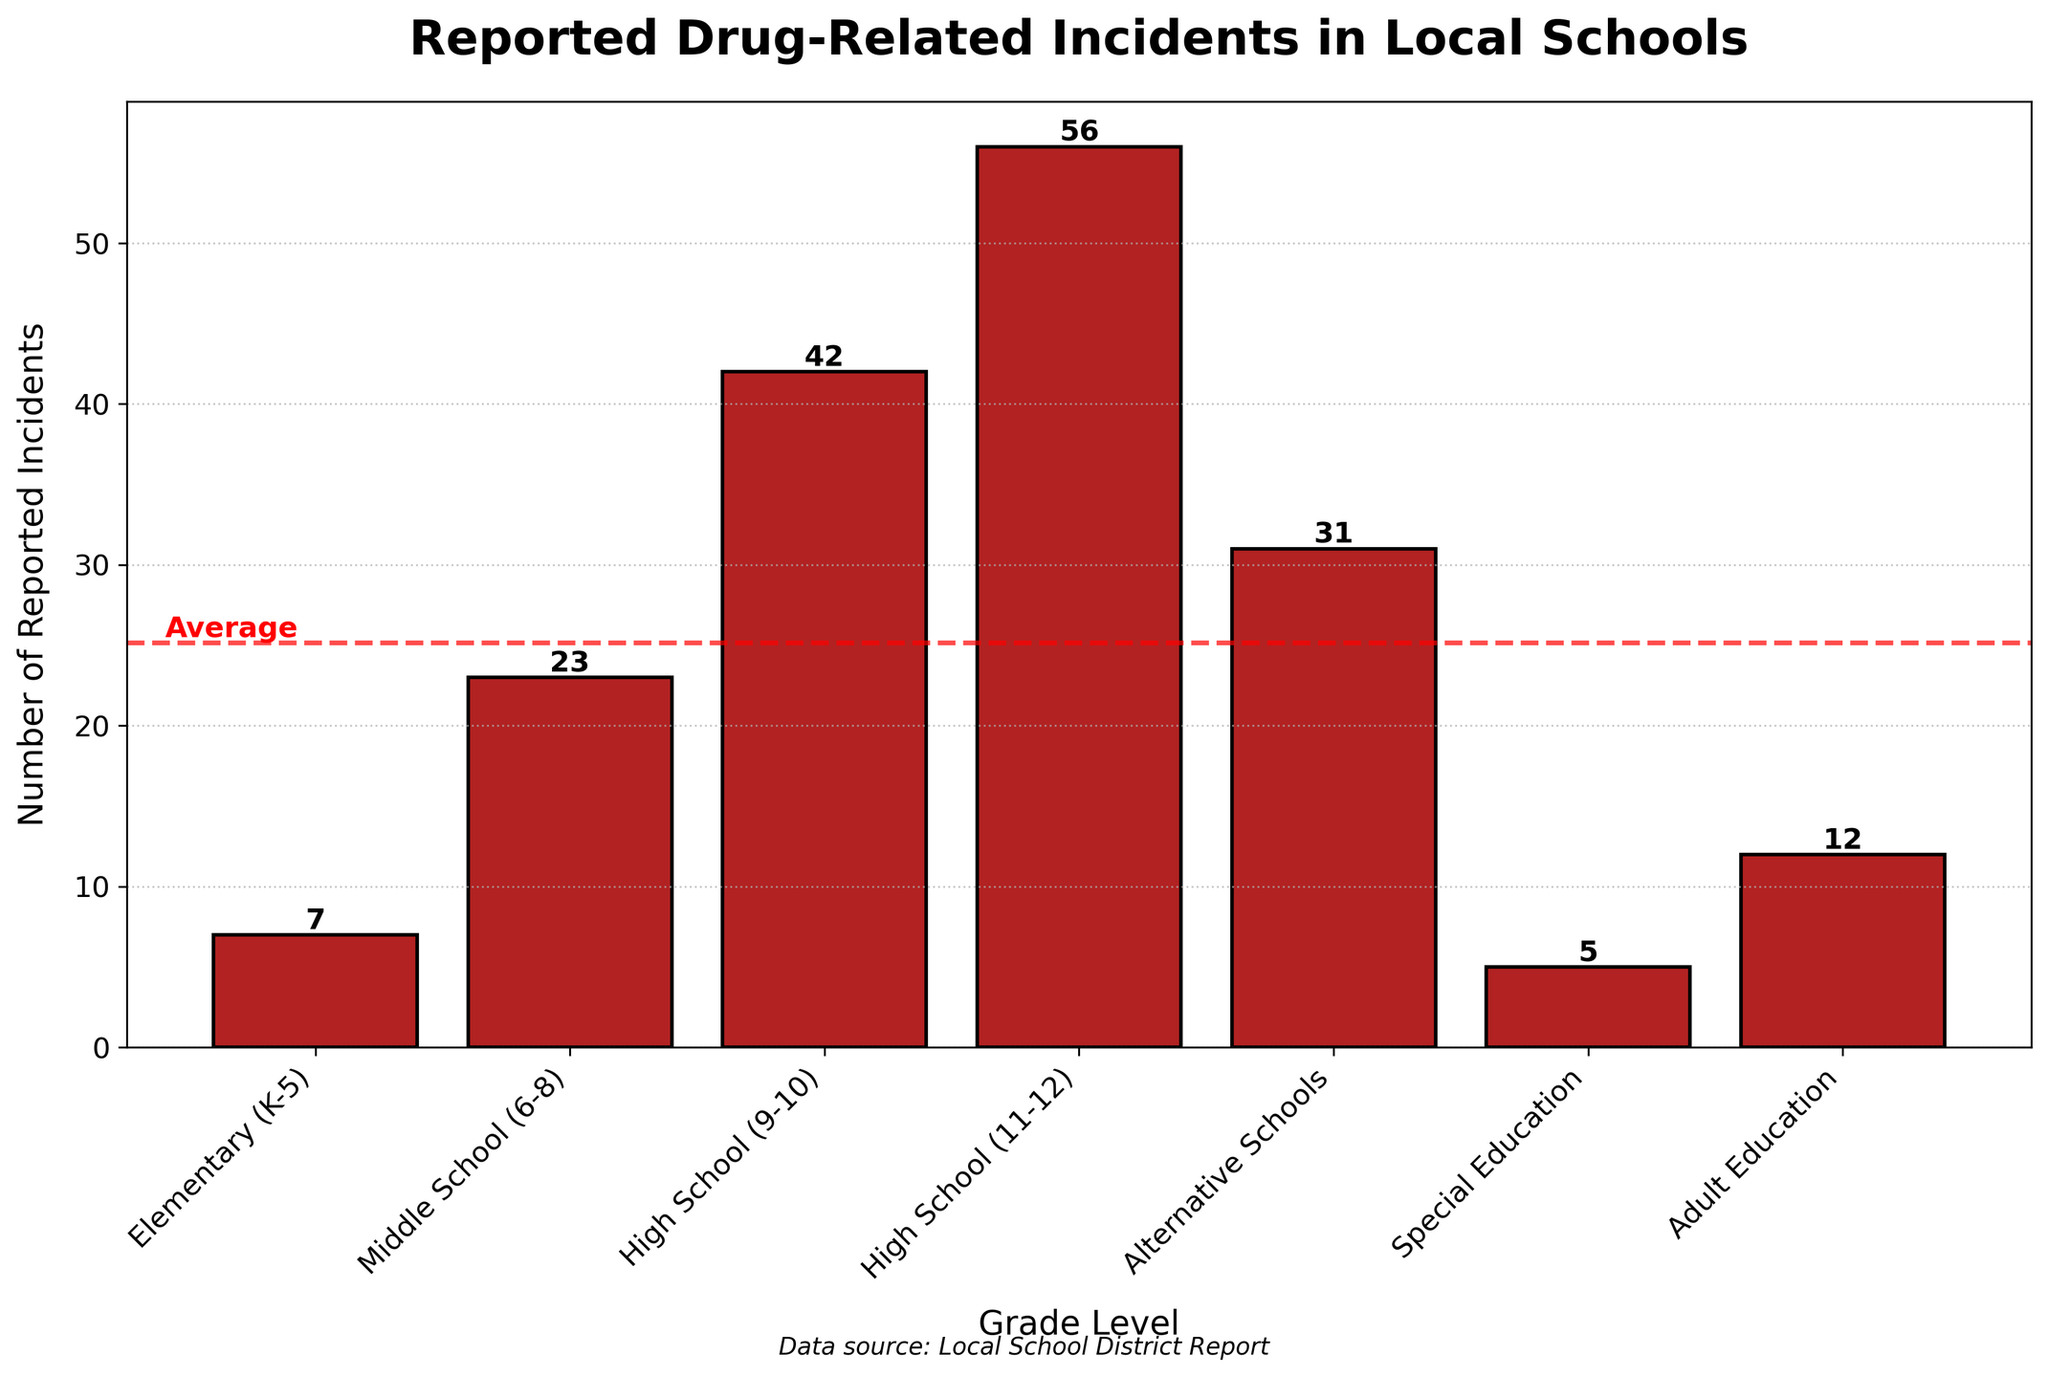Which grade level has the highest number of reported drug incidents? To determine which grade level has the highest number of reported drug incidents, look for the tallest bar in the bar chart. The bar for "High School (11-12)" is the tallest, indicating that it has the highest number.
Answer: High School (11-12) How many more reported drug incidents are there in High School (11-12) than in Elementary (K-5)? The number of reported drug incidents in High School (11-12) is 56 and in Elementary (K-5) is 7. Subtract the two to find the difference: 56 - 7 = 49.
Answer: 49 What is the average number of reported drug incidents across all grade levels? To calculate the average, sum all the incidents and divide by the number of grade levels. The sum is 7 + 23 + 42 + 56 + 31 + 5 + 12 = 176. There are 7 grade levels, so the average is 176 / 7 ≈ 25.
Answer: 25 Is the number of reported drug incidents in Alternative Schools above or below the average? The average number of incidents is approximately 25. The bar for Alternative Schools shows 31 incidents, which is above the average.
Answer: Above How many reported drug incidents are there in total for both High School grade categories combined? Combine the incidents from High School (9-10) and High School (11-12). The total is 42 + 56 = 98.
Answer: 98 Which grade level has the lowest number of reported drug incidents? To find the grade level with the lowest number of incidents, look for the shortest bar in the chart. The shortest bar corresponds to Special Education, which has 5 incidents.
Answer: Special Education What is the difference in reported drug incidents between Middle School (6-8) and Adult Education? The number of incidents in Middle School (6-8) is 23, and in Adult Education it is 12. The difference is 23 - 12 = 11.
Answer: 11 Is there a significant increase in the number of reported drug incidents moving from Elementary (K-5) to Middle School (6-8)? Compare the number of incidents between Elementary (K-5) and Middle School (6-8). Elementary has 7 incidents and Middle School has 23. There is a significant increase of 23 - 7 = 16 incidents.
Answer: Yes What is the combined total of incidents in all grade levels besides Alternative Schools? Sum the incidents for all grade levels excluding Alternative Schools: 7 + 23 + 42 + 56 + 5 + 12 = 145.
Answer: 145 Which grade level has more reported drug incidents: Special Education or Adult Education? Compare the bars for Special Education and Adult Education. Special Education has 5 incidents, and Adult Education has 12. Adult Education has more incidents.
Answer: Adult Education 